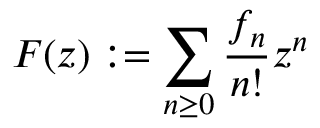<formula> <loc_0><loc_0><loc_500><loc_500>F ( z ) \colon = \sum _ { n \geq 0 } { \frac { f _ { n } } { n ! } } z ^ { n }</formula> 